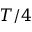<formula> <loc_0><loc_0><loc_500><loc_500>T / 4</formula> 